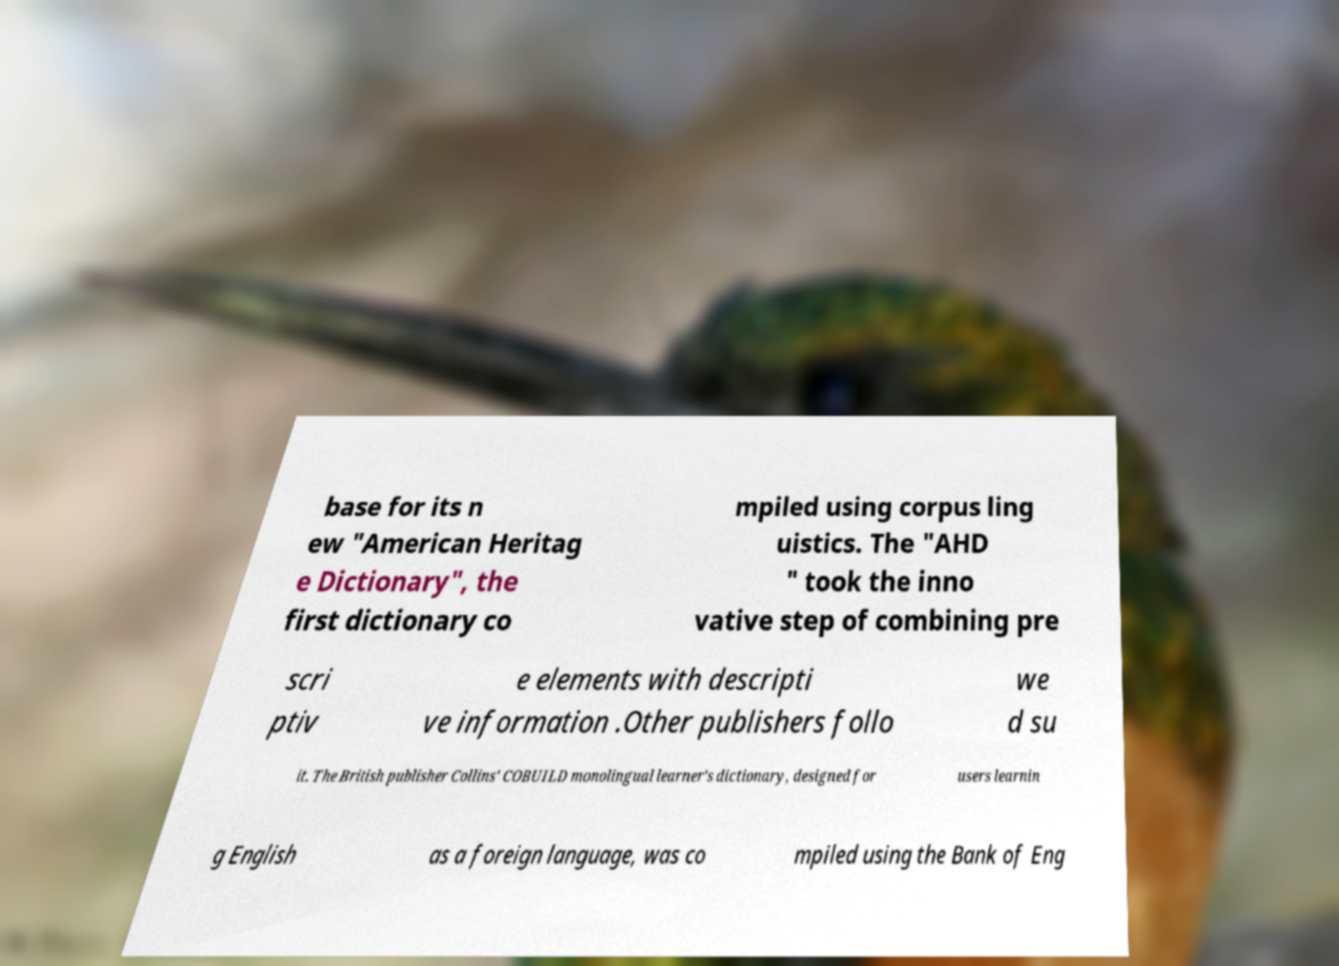What messages or text are displayed in this image? I need them in a readable, typed format. base for its n ew "American Heritag e Dictionary", the first dictionary co mpiled using corpus ling uistics. The "AHD " took the inno vative step of combining pre scri ptiv e elements with descripti ve information .Other publishers follo we d su it. The British publisher Collins' COBUILD monolingual learner's dictionary, designed for users learnin g English as a foreign language, was co mpiled using the Bank of Eng 